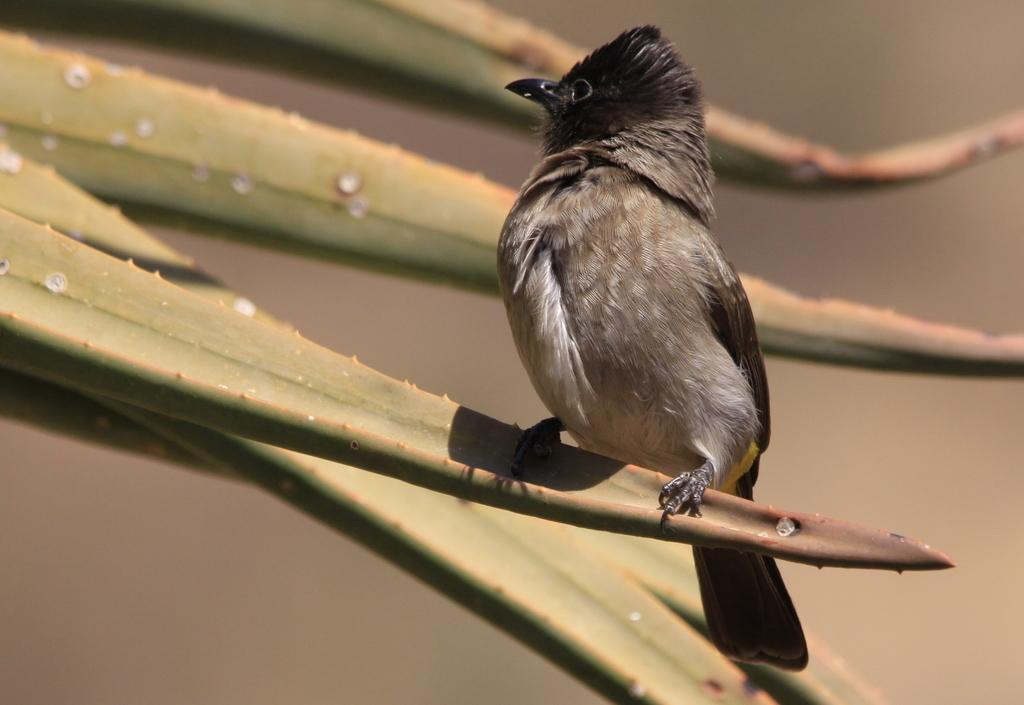What type of animal can be seen in the image? There is a bird in the image. Where is the bird located? The bird is standing on a plant. Can you describe the background of the image? The background of the image is blurry. How many chairs are visible in the image? There are no chairs present in the image; it features a bird standing on a plant with a blurry background. 